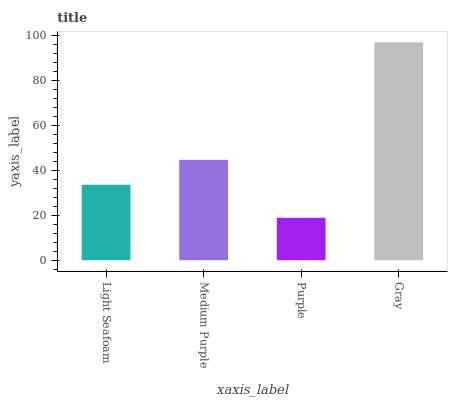Is Purple the minimum?
Answer yes or no. Yes. Is Gray the maximum?
Answer yes or no. Yes. Is Medium Purple the minimum?
Answer yes or no. No. Is Medium Purple the maximum?
Answer yes or no. No. Is Medium Purple greater than Light Seafoam?
Answer yes or no. Yes. Is Light Seafoam less than Medium Purple?
Answer yes or no. Yes. Is Light Seafoam greater than Medium Purple?
Answer yes or no. No. Is Medium Purple less than Light Seafoam?
Answer yes or no. No. Is Medium Purple the high median?
Answer yes or no. Yes. Is Light Seafoam the low median?
Answer yes or no. Yes. Is Purple the high median?
Answer yes or no. No. Is Medium Purple the low median?
Answer yes or no. No. 